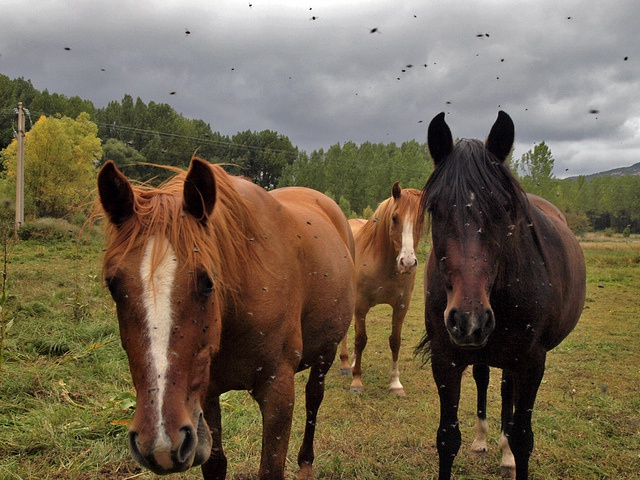Describe the objects in this image and their specific colors. I can see horse in white, black, maroon, and brown tones, horse in white, black, maroon, and gray tones, and horse in white, maroon, brown, and black tones in this image. 